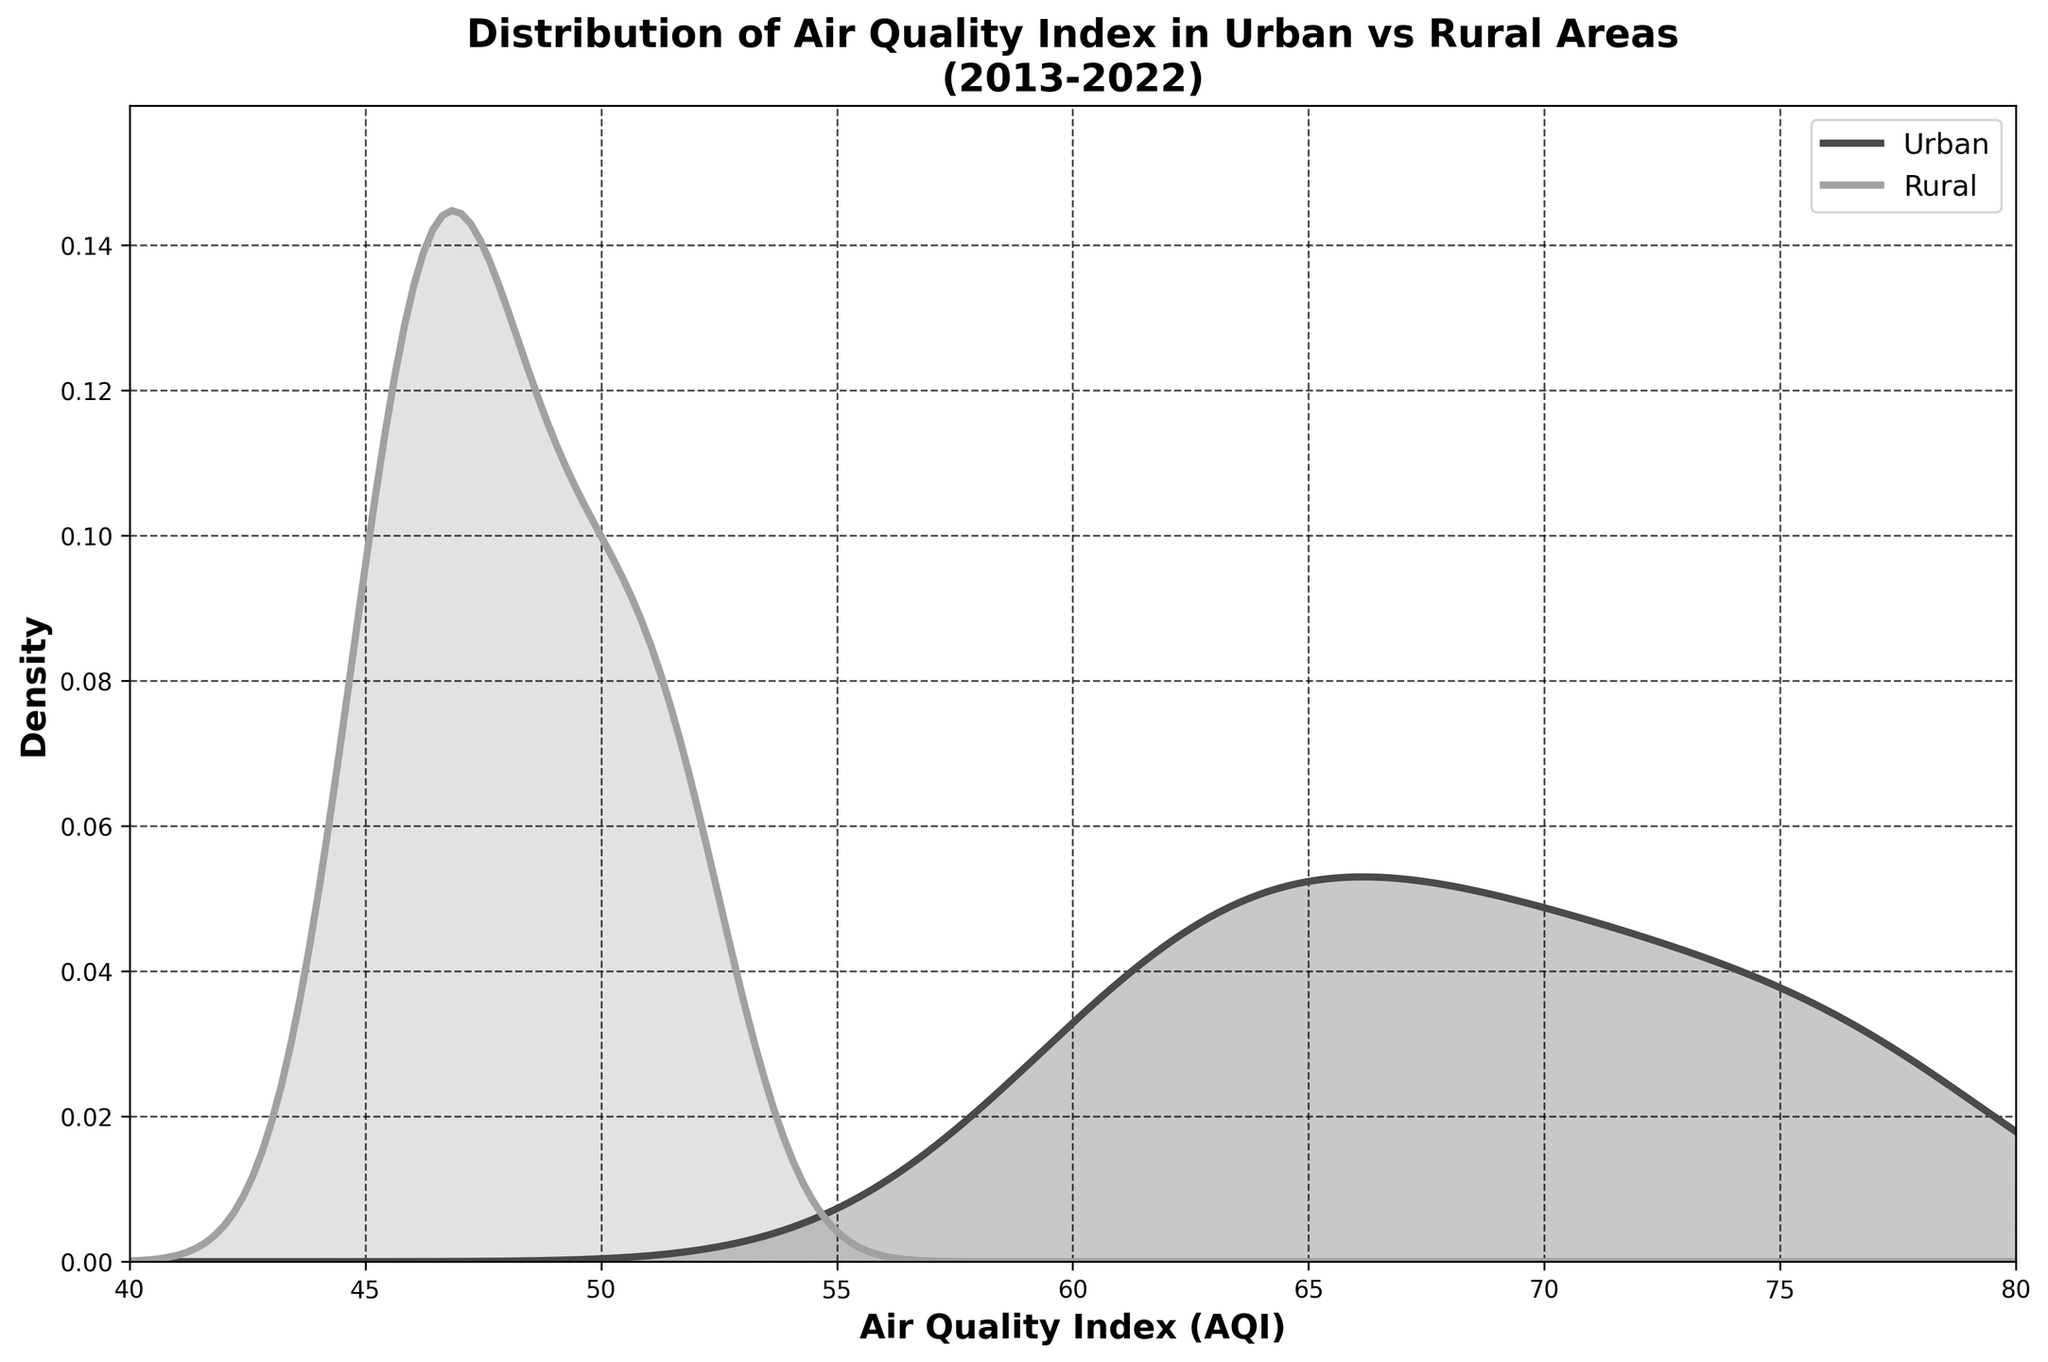What is the title of the figure? The title of the figure is displayed prominently at the top, it reads "Distribution of Air Quality Index in Urban vs Rural Areas\n(2013-2022)".
Answer: Distribution of Air Quality Index in Urban vs Rural Areas\n(2013-2022) What are the labels of the axes? The x-axis and y-axis labels are indicated along the respective axes. The x-axis is labeled 'Air Quality Index (AQI)' and the y-axis is labeled 'Density'.
Answer: Air Quality Index (AQI) and Density How do the densities of Urban and Rural areas compare around an AQI of 50? By examining the plot, both density curves show that the rural density is higher than the urban density around an AQI of 50, as visualized by the height of the grey curve being greater than the black curve.
Answer: Rural density is higher Which area has a peak density value at a lower AQI value? The peak density for Rural areas occurs at a lower AQI value compared to Urban areas, as inferred from the x-axis position of the peaks of the grey and black curves respectively.
Answer: Rural areas At which AQI value do the Urban and Rural densities intersect? The intersection point can be found where the black and grey curves cross each other. This occurs around an AQI value close to 46.
Answer: Around 46 What can be inferred about the AQI trends in urban areas over the past decade? Observing the density plot, the urban AQI values span a higher range with a peak density at a higher AQI compared to rural AQI, indicating generally poorer air quality in urban areas over the past decade.
Answer: Poorer air quality in urban areas How does the distribution of AQI values from 60 to 80 compare between Urban and Rural areas? The urban density curve is generally higher in this range compared to the rural curve, indicating that urban areas more frequently experience AQI values in this higher range.
Answer: Urban density is higher What is the trend in rural AQI values from 2013 to 2022? According to the density plot, the rural AQI distributions are concentrated in a lower range with consistent density values, suggesting generally stable and better air quality compared to urban areas.
Answer: Stable and better air quality Are there any AQI values where the density for urban areas drastically drops? The urban density curve drastically drops as the AQI approaches values lower than 60. This is evident from the sharp decline in the black curve.
Answer: AQI approaching lower than 60 Between which two AQI values does the rural density have the most steep ascent or descent? The steepest ascent in the rural density curve is observed between AQI values of 45 and 50. This is indicated by the sharp rise in the grey curve within this range.
Answer: Between 45 and 50 